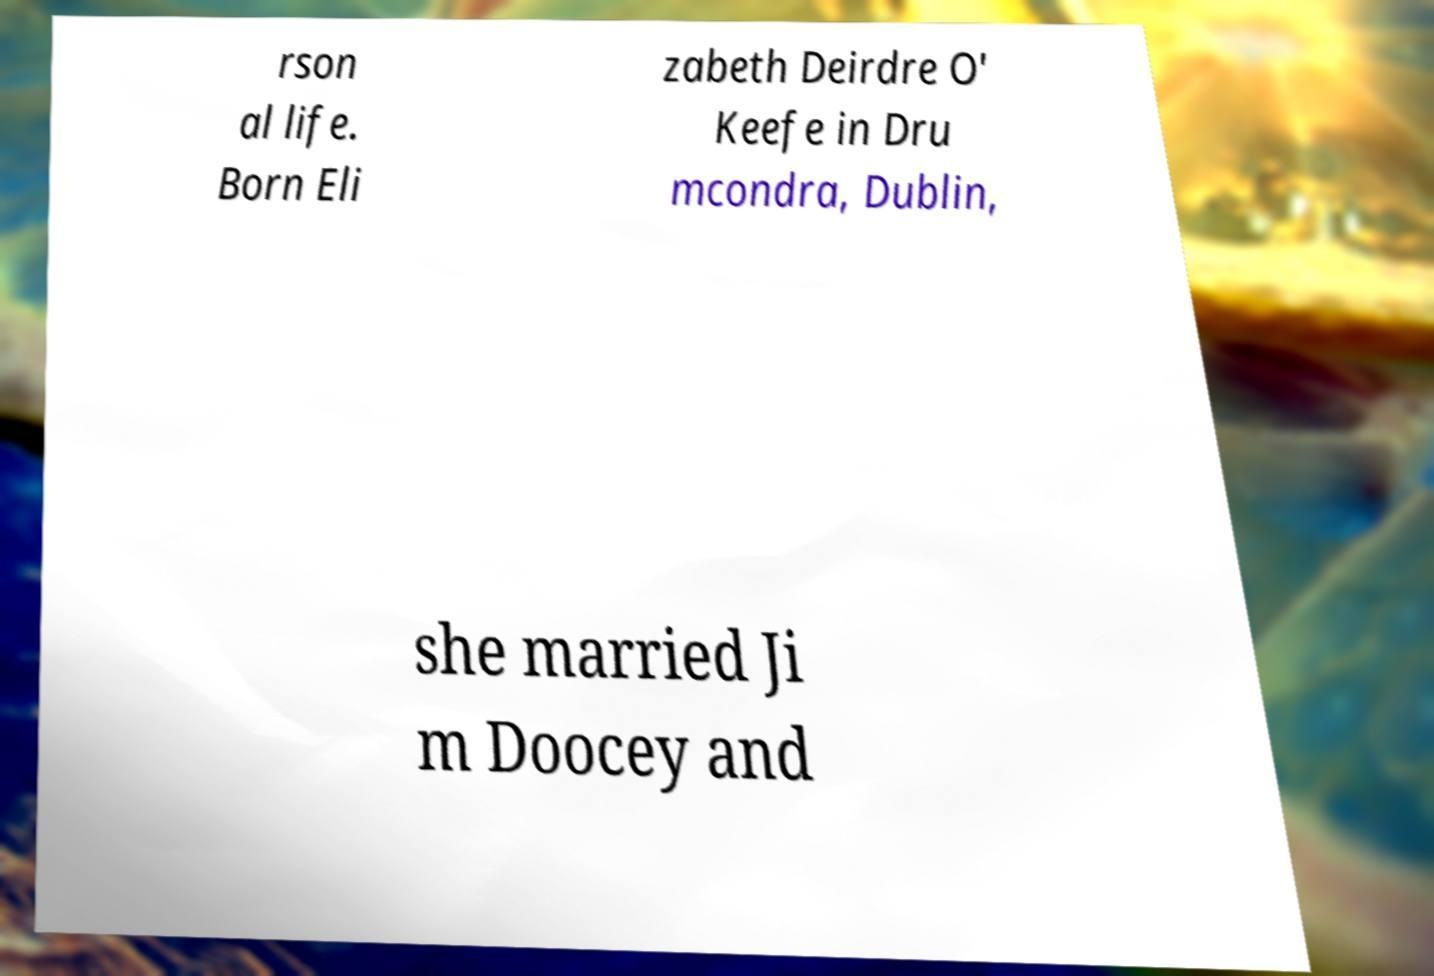Please read and relay the text visible in this image. What does it say? rson al life. Born Eli zabeth Deirdre O' Keefe in Dru mcondra, Dublin, she married Ji m Doocey and 